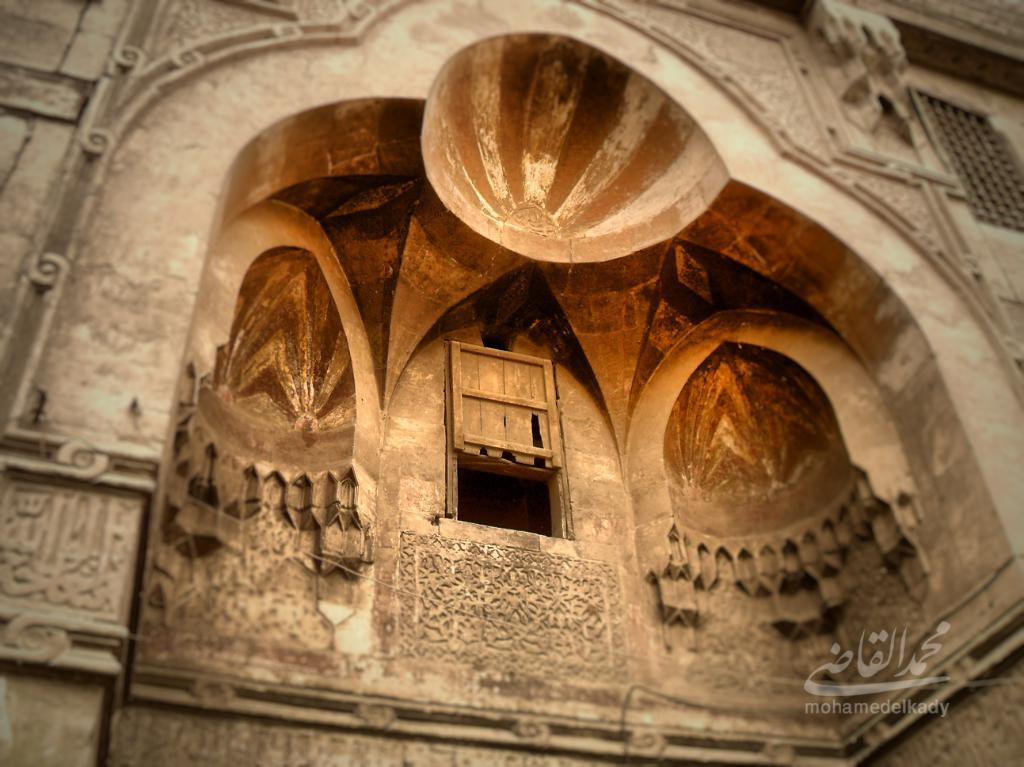What type of structure is visible in the image? There is a building in the image. What feature can be seen on the building? The building has windows. Can you describe any other architectural details in the image? There is a wall with carvings in the image. Is there any additional information about the image itself? There is a watermark in the bottom left corner of the image. What is the condition of the field in the image? There is no field present in the image; it features a building with windows and a wall with carvings. 